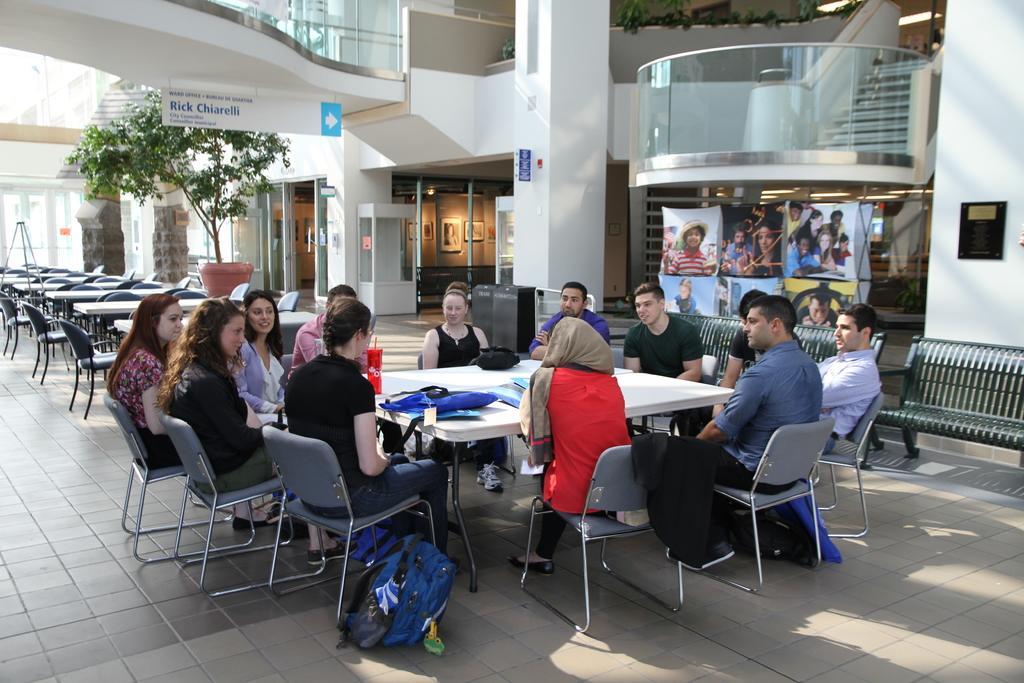Describe this image in one or two sentences. In an organisation there are many chairs and tables placed in the hall and around one of the table a group of people are sitting and discussing,behind them there are steps to the upper level and around people there are different rooms and posters and in the background there is a tree. 